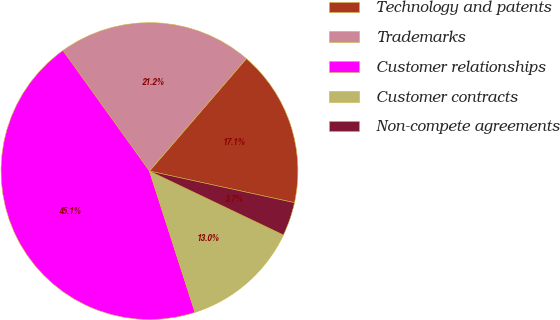Convert chart. <chart><loc_0><loc_0><loc_500><loc_500><pie_chart><fcel>Technology and patents<fcel>Trademarks<fcel>Customer relationships<fcel>Customer contracts<fcel>Non-compete agreements<nl><fcel>17.09%<fcel>21.23%<fcel>45.05%<fcel>12.95%<fcel>3.67%<nl></chart> 